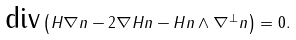<formula> <loc_0><loc_0><loc_500><loc_500>\text {div} \left ( H \nabla n - 2 \nabla H n - H n \wedge \nabla ^ { \perp } n \right ) = 0 .</formula> 